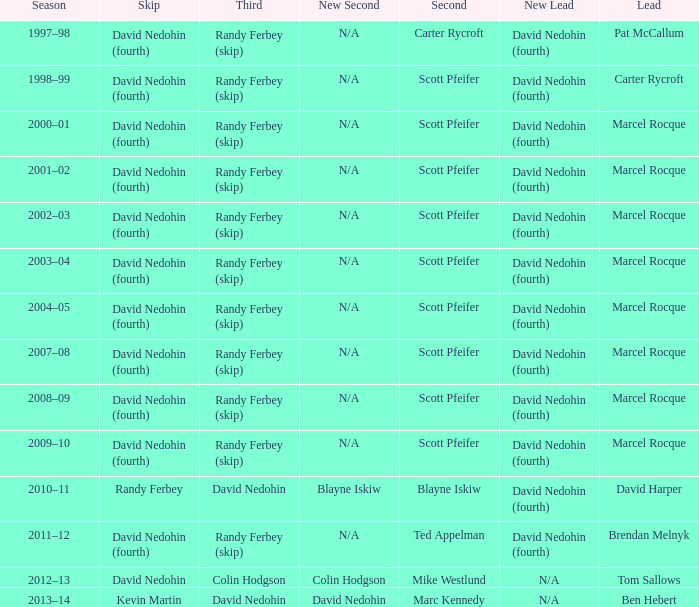I'm looking to parse the entire table for insights. Could you assist me with that? {'header': ['Season', 'Skip', 'Third', 'New Second', 'Second', 'New Lead', 'Lead'], 'rows': [['1997–98', 'David Nedohin (fourth)', 'Randy Ferbey (skip)', 'N/A', 'Carter Rycroft', 'David Nedohin (fourth)', 'Pat McCallum'], ['1998–99', 'David Nedohin (fourth)', 'Randy Ferbey (skip)', 'N/A', 'Scott Pfeifer', 'David Nedohin (fourth)', 'Carter Rycroft'], ['2000–01', 'David Nedohin (fourth)', 'Randy Ferbey (skip)', 'N/A', 'Scott Pfeifer', 'David Nedohin (fourth)', 'Marcel Rocque'], ['2001–02', 'David Nedohin (fourth)', 'Randy Ferbey (skip)', 'N/A', 'Scott Pfeifer', 'David Nedohin (fourth)', 'Marcel Rocque'], ['2002–03', 'David Nedohin (fourth)', 'Randy Ferbey (skip)', 'N/A', 'Scott Pfeifer', 'David Nedohin (fourth)', 'Marcel Rocque'], ['2003–04', 'David Nedohin (fourth)', 'Randy Ferbey (skip)', 'N/A', 'Scott Pfeifer', 'David Nedohin (fourth)', 'Marcel Rocque'], ['2004–05', 'David Nedohin (fourth)', 'Randy Ferbey (skip)', 'N/A', 'Scott Pfeifer', 'David Nedohin (fourth)', 'Marcel Rocque'], ['2007–08', 'David Nedohin (fourth)', 'Randy Ferbey (skip)', 'N/A', 'Scott Pfeifer', 'David Nedohin (fourth)', 'Marcel Rocque'], ['2008–09', 'David Nedohin (fourth)', 'Randy Ferbey (skip)', 'N/A', 'Scott Pfeifer', 'David Nedohin (fourth)', 'Marcel Rocque'], ['2009–10', 'David Nedohin (fourth)', 'Randy Ferbey (skip)', 'N/A', 'Scott Pfeifer', 'David Nedohin (fourth)', 'Marcel Rocque'], ['2010–11', 'Randy Ferbey', 'David Nedohin', 'Blayne Iskiw', 'Blayne Iskiw', 'David Nedohin (fourth)', 'David Harper'], ['2011–12', 'David Nedohin (fourth)', 'Randy Ferbey (skip)', 'N/A', 'Ted Appelman', 'David Nedohin (fourth)', 'Brendan Melnyk'], ['2012–13', 'David Nedohin', 'Colin Hodgson', 'Colin Hodgson', 'Mike Westlund', 'N/A', 'Tom Sallows'], ['2013–14', 'Kevin Martin', 'David Nedohin', 'David Nedohin', 'Marc Kennedy', 'N/A', 'Ben Hebert']]} Which Skip has a Season of 2002–03? David Nedohin (fourth). 